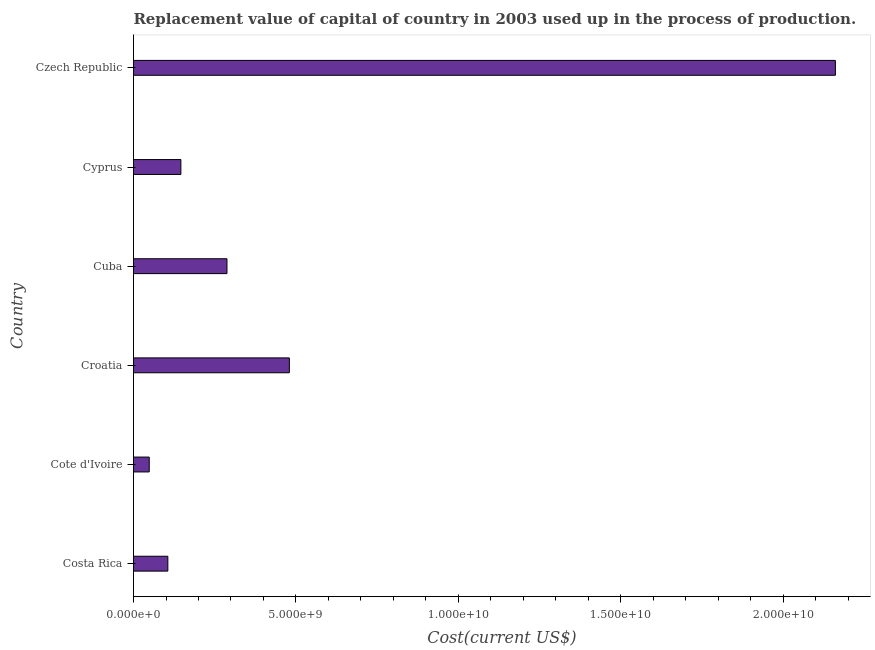What is the title of the graph?
Your response must be concise. Replacement value of capital of country in 2003 used up in the process of production. What is the label or title of the X-axis?
Provide a succinct answer. Cost(current US$). What is the label or title of the Y-axis?
Ensure brevity in your answer.  Country. What is the consumption of fixed capital in Croatia?
Your answer should be compact. 4.80e+09. Across all countries, what is the maximum consumption of fixed capital?
Provide a succinct answer. 2.16e+1. Across all countries, what is the minimum consumption of fixed capital?
Keep it short and to the point. 4.84e+08. In which country was the consumption of fixed capital maximum?
Your response must be concise. Czech Republic. In which country was the consumption of fixed capital minimum?
Keep it short and to the point. Cote d'Ivoire. What is the sum of the consumption of fixed capital?
Ensure brevity in your answer.  3.23e+1. What is the difference between the consumption of fixed capital in Costa Rica and Cote d'Ivoire?
Your answer should be compact. 5.73e+08. What is the average consumption of fixed capital per country?
Keep it short and to the point. 5.38e+09. What is the median consumption of fixed capital?
Keep it short and to the point. 2.17e+09. In how many countries, is the consumption of fixed capital greater than 10000000000 US$?
Make the answer very short. 1. What is the ratio of the consumption of fixed capital in Cote d'Ivoire to that in Cuba?
Your answer should be very brief. 0.17. Is the difference between the consumption of fixed capital in Cyprus and Czech Republic greater than the difference between any two countries?
Your answer should be very brief. No. What is the difference between the highest and the second highest consumption of fixed capital?
Provide a short and direct response. 1.68e+1. Is the sum of the consumption of fixed capital in Cuba and Czech Republic greater than the maximum consumption of fixed capital across all countries?
Your answer should be compact. Yes. What is the difference between the highest and the lowest consumption of fixed capital?
Your response must be concise. 2.11e+1. In how many countries, is the consumption of fixed capital greater than the average consumption of fixed capital taken over all countries?
Provide a short and direct response. 1. How many countries are there in the graph?
Your response must be concise. 6. What is the Cost(current US$) of Costa Rica?
Ensure brevity in your answer.  1.06e+09. What is the Cost(current US$) of Cote d'Ivoire?
Your answer should be very brief. 4.84e+08. What is the Cost(current US$) of Croatia?
Your answer should be very brief. 4.80e+09. What is the Cost(current US$) in Cuba?
Your answer should be compact. 2.88e+09. What is the Cost(current US$) of Cyprus?
Your response must be concise. 1.46e+09. What is the Cost(current US$) of Czech Republic?
Your answer should be very brief. 2.16e+1. What is the difference between the Cost(current US$) in Costa Rica and Cote d'Ivoire?
Your response must be concise. 5.73e+08. What is the difference between the Cost(current US$) in Costa Rica and Croatia?
Provide a succinct answer. -3.74e+09. What is the difference between the Cost(current US$) in Costa Rica and Cuba?
Provide a succinct answer. -1.82e+09. What is the difference between the Cost(current US$) in Costa Rica and Cyprus?
Your answer should be compact. -4.01e+08. What is the difference between the Cost(current US$) in Costa Rica and Czech Republic?
Ensure brevity in your answer.  -2.05e+1. What is the difference between the Cost(current US$) in Cote d'Ivoire and Croatia?
Keep it short and to the point. -4.31e+09. What is the difference between the Cost(current US$) in Cote d'Ivoire and Cuba?
Your answer should be compact. -2.39e+09. What is the difference between the Cost(current US$) in Cote d'Ivoire and Cyprus?
Offer a terse response. -9.74e+08. What is the difference between the Cost(current US$) in Cote d'Ivoire and Czech Republic?
Give a very brief answer. -2.11e+1. What is the difference between the Cost(current US$) in Croatia and Cuba?
Offer a very short reply. 1.92e+09. What is the difference between the Cost(current US$) in Croatia and Cyprus?
Offer a very short reply. 3.34e+09. What is the difference between the Cost(current US$) in Croatia and Czech Republic?
Offer a terse response. -1.68e+1. What is the difference between the Cost(current US$) in Cuba and Cyprus?
Keep it short and to the point. 1.42e+09. What is the difference between the Cost(current US$) in Cuba and Czech Republic?
Your answer should be compact. -1.87e+1. What is the difference between the Cost(current US$) in Cyprus and Czech Republic?
Your answer should be compact. -2.01e+1. What is the ratio of the Cost(current US$) in Costa Rica to that in Cote d'Ivoire?
Your answer should be compact. 2.18. What is the ratio of the Cost(current US$) in Costa Rica to that in Croatia?
Offer a very short reply. 0.22. What is the ratio of the Cost(current US$) in Costa Rica to that in Cuba?
Your answer should be compact. 0.37. What is the ratio of the Cost(current US$) in Costa Rica to that in Cyprus?
Keep it short and to the point. 0.72. What is the ratio of the Cost(current US$) in Costa Rica to that in Czech Republic?
Give a very brief answer. 0.05. What is the ratio of the Cost(current US$) in Cote d'Ivoire to that in Croatia?
Your answer should be very brief. 0.1. What is the ratio of the Cost(current US$) in Cote d'Ivoire to that in Cuba?
Offer a very short reply. 0.17. What is the ratio of the Cost(current US$) in Cote d'Ivoire to that in Cyprus?
Provide a short and direct response. 0.33. What is the ratio of the Cost(current US$) in Cote d'Ivoire to that in Czech Republic?
Keep it short and to the point. 0.02. What is the ratio of the Cost(current US$) in Croatia to that in Cuba?
Give a very brief answer. 1.67. What is the ratio of the Cost(current US$) in Croatia to that in Cyprus?
Provide a succinct answer. 3.29. What is the ratio of the Cost(current US$) in Croatia to that in Czech Republic?
Keep it short and to the point. 0.22. What is the ratio of the Cost(current US$) in Cuba to that in Cyprus?
Ensure brevity in your answer.  1.97. What is the ratio of the Cost(current US$) in Cuba to that in Czech Republic?
Offer a terse response. 0.13. What is the ratio of the Cost(current US$) in Cyprus to that in Czech Republic?
Give a very brief answer. 0.07. 